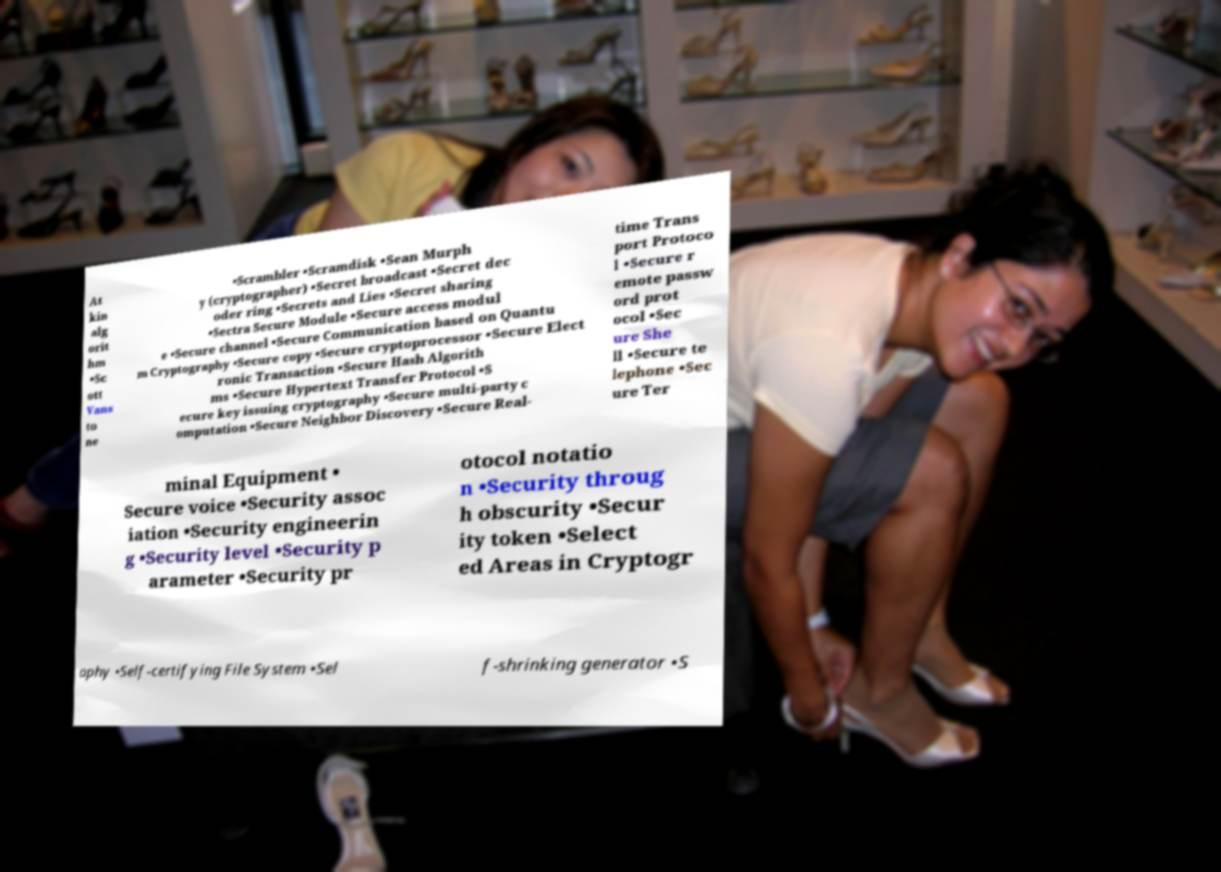There's text embedded in this image that I need extracted. Can you transcribe it verbatim? At kin alg orit hm •Sc ott Vans to ne •Scrambler •Scramdisk •Sean Murph y (cryptographer) •Secret broadcast •Secret dec oder ring •Secrets and Lies •Secret sharing •Sectra Secure Module •Secure access modul e •Secure channel •Secure Communication based on Quantu m Cryptography •Secure copy •Secure cryptoprocessor •Secure Elect ronic Transaction •Secure Hash Algorith ms •Secure Hypertext Transfer Protocol •S ecure key issuing cryptography •Secure multi-party c omputation •Secure Neighbor Discovery •Secure Real- time Trans port Protoco l •Secure r emote passw ord prot ocol •Sec ure She ll •Secure te lephone •Sec ure Ter minal Equipment • Secure voice •Security assoc iation •Security engineerin g •Security level •Security p arameter •Security pr otocol notatio n •Security throug h obscurity •Secur ity token •Select ed Areas in Cryptogr aphy •Self-certifying File System •Sel f-shrinking generator •S 